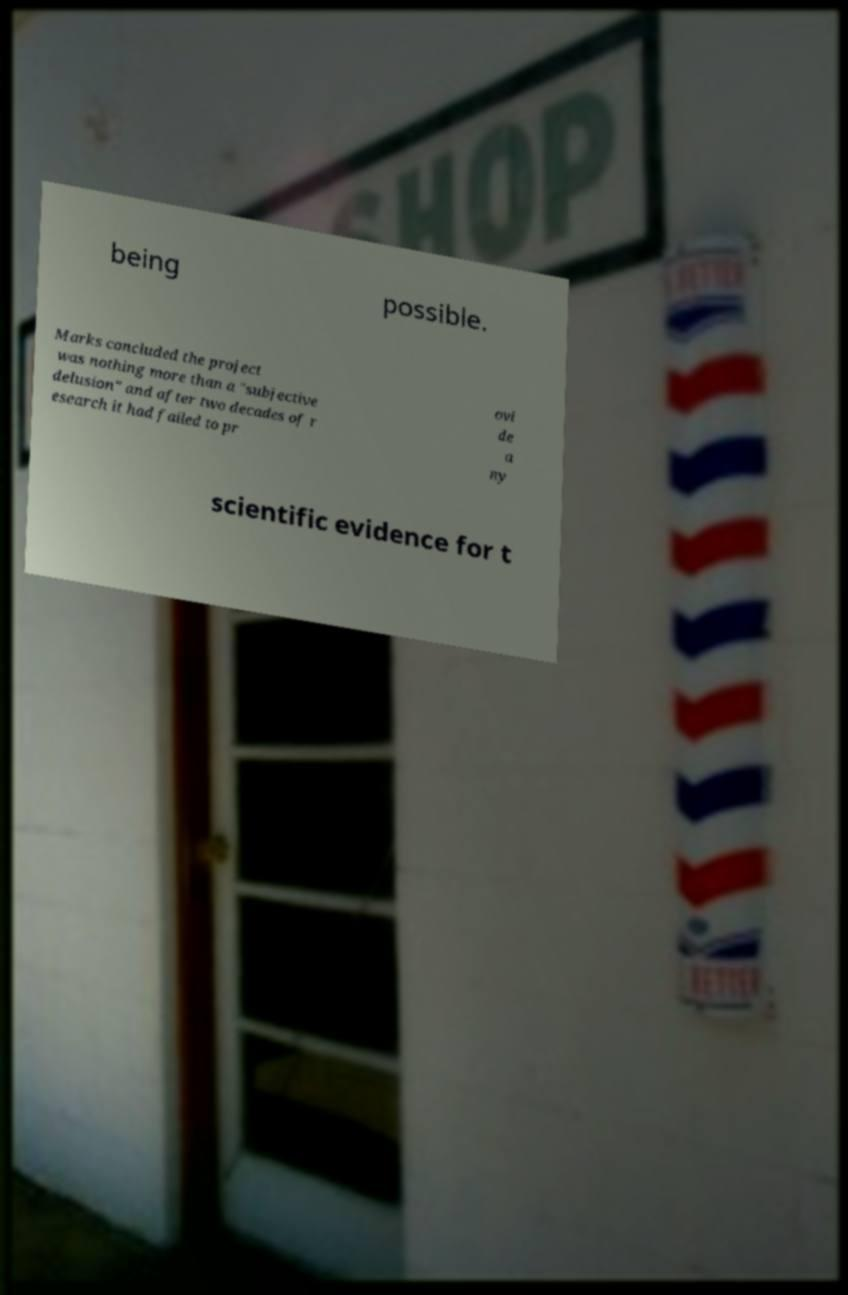Could you assist in decoding the text presented in this image and type it out clearly? being possible. Marks concluded the project was nothing more than a "subjective delusion" and after two decades of r esearch it had failed to pr ovi de a ny scientific evidence for t 